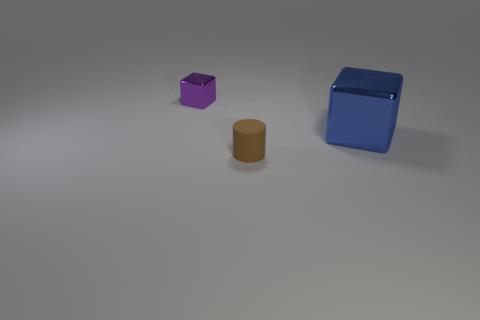Add 3 tiny blue metallic cylinders. How many objects exist? 6 Subtract all cylinders. How many objects are left? 2 Subtract all small purple cubes. Subtract all tiny brown matte cylinders. How many objects are left? 1 Add 3 brown things. How many brown things are left? 4 Add 1 purple cubes. How many purple cubes exist? 2 Subtract 0 blue cylinders. How many objects are left? 3 